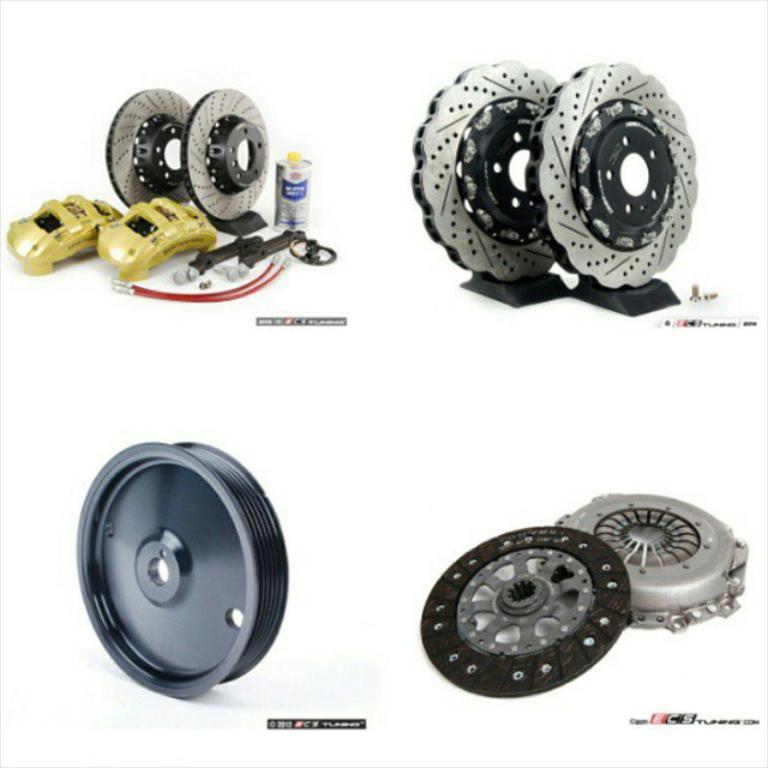How would you summarize this image in a sentence or two? In this image I can see few brake discs and few objects. I can see few parts of the car. Background is in white color. 